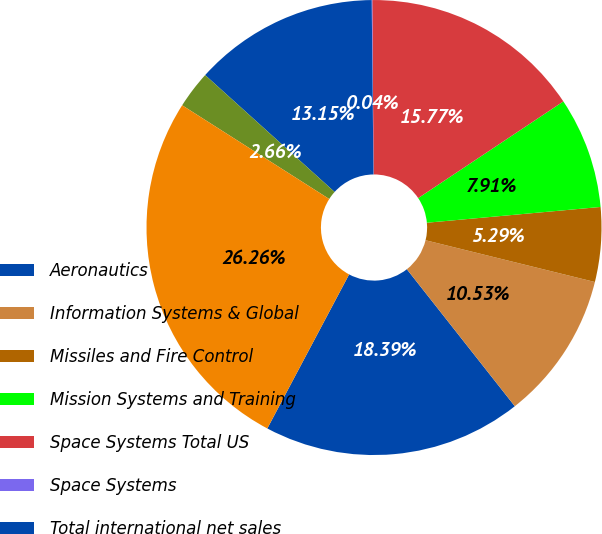<chart> <loc_0><loc_0><loc_500><loc_500><pie_chart><fcel>Aeronautics<fcel>Information Systems & Global<fcel>Missiles and Fire Control<fcel>Mission Systems and Training<fcel>Space Systems Total US<fcel>Space Systems<fcel>Total international net sales<fcel>Total US commercial and other<fcel>Total net sales<nl><fcel>18.39%<fcel>10.53%<fcel>5.29%<fcel>7.91%<fcel>15.77%<fcel>0.04%<fcel>13.15%<fcel>2.66%<fcel>26.26%<nl></chart> 